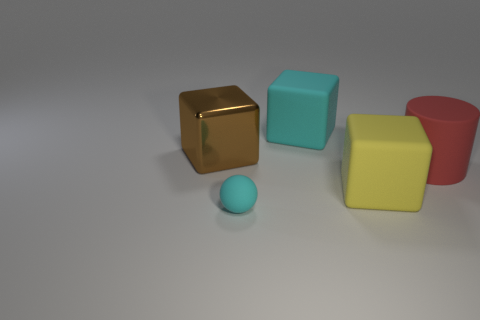What number of other things are the same color as the matte sphere?
Provide a succinct answer. 1. There is a cyan object in front of the matte block that is in front of the matte object that is behind the large metallic cube; what is it made of?
Your answer should be very brief. Rubber. How many cylinders are either large green things or cyan objects?
Give a very brief answer. 0. Is there anything else that has the same size as the metal object?
Provide a succinct answer. Yes. There is a matte cube that is in front of the cyan thing behind the big cylinder; how many big objects are to the left of it?
Ensure brevity in your answer.  2. Is the shape of the big yellow matte object the same as the shiny thing?
Keep it short and to the point. Yes. Is the large thing that is behind the big brown cube made of the same material as the thing that is in front of the yellow rubber thing?
Ensure brevity in your answer.  Yes. How many objects are blocks that are on the left side of the yellow matte cube or objects that are behind the cyan matte ball?
Keep it short and to the point. 4. Are there any other things that have the same shape as the tiny matte object?
Provide a succinct answer. No. How many tiny red shiny objects are there?
Your answer should be very brief. 0. 